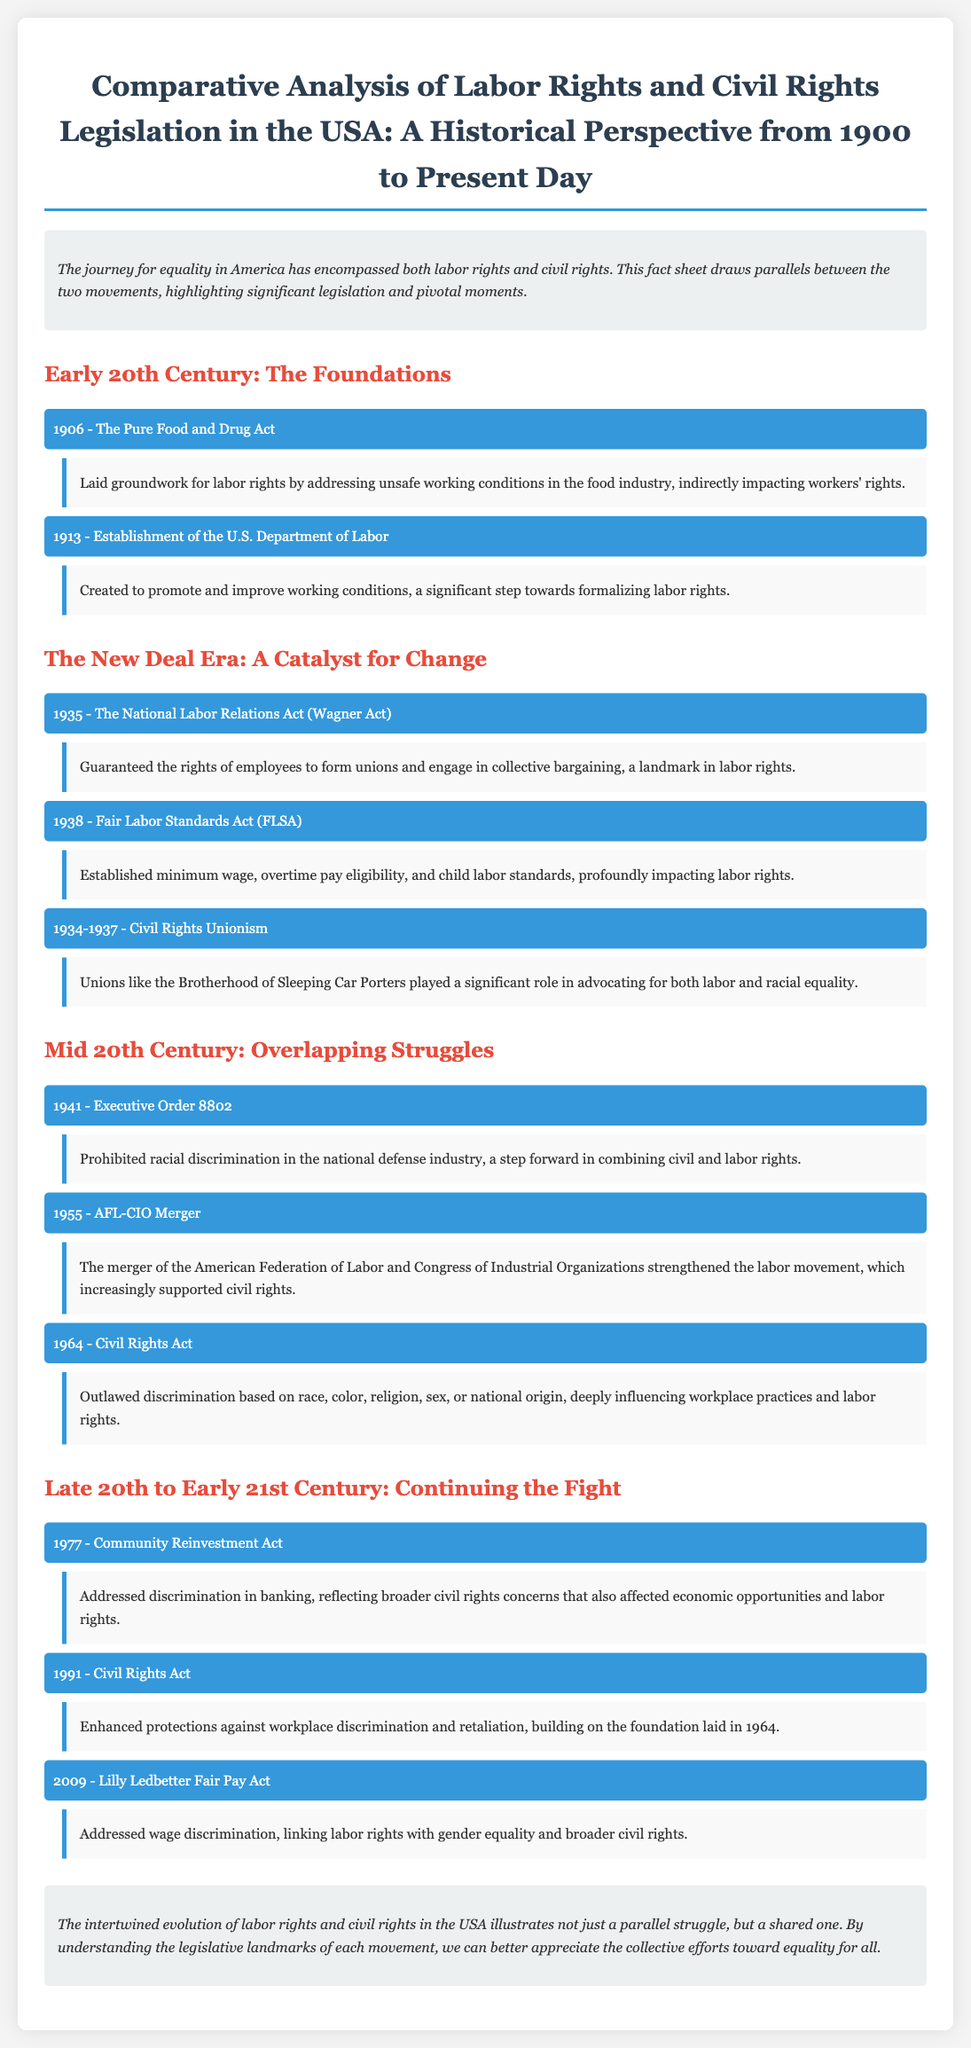What year was the National Labor Relations Act enacted? The document states that the National Labor Relations Act, also known as the Wagner Act, was enacted in 1935.
Answer: 1935 What piece of legislation established minimum wage? The Fair Labor Standards Act, mentioned in the document, established minimum wage in 1938.
Answer: Fair Labor Standards Act Which merger strengthened the labor movement and supported civil rights? The merger of the American Federation of Labor and the Congress of Industrial Organizations in 1955 is highlighted as strengthening the labor movement.
Answer: AFL-CIO Merger What was the key focus of Executive Order 8802? The document indicates that Executive Order 8802 prohibited racial discrimination in the national defense industry, addressing civil rights and labor rights.
Answer: Racial discrimination What act enhanced protections against workplace discrimination in 1991? The Civil Rights Act of 1991 is described as enhancing protections against workplace discrimination and retaliation.
Answer: Civil Rights Act How did the Lilly Ledbetter Fair Pay Act link labor rights with civil rights? The document notes that the Lilly Ledbetter Fair Pay Act addressed wage discrimination, linking labor rights with gender equality and broader civil rights.
Answer: Wage discrimination What major issue did the Community Reinvestment Act address in 1977? The Community Reinvestment Act addressed discrimination in banking, reflecting civil rights concerns in connection to labor rights.
Answer: Discrimination in banking What significant act was passed in 1964? The Civil Rights Act, which outlawed discrimination based on various factors, was passed in 1964.
Answer: Civil Rights Act What organization played a role in Civil Rights Unionism from 1934 to 1937? The Brotherhood of Sleeping Car Porters is specifically mentioned as a significant union in the context of Civil Rights Unionism.
Answer: Brotherhood of Sleeping Car Porters 